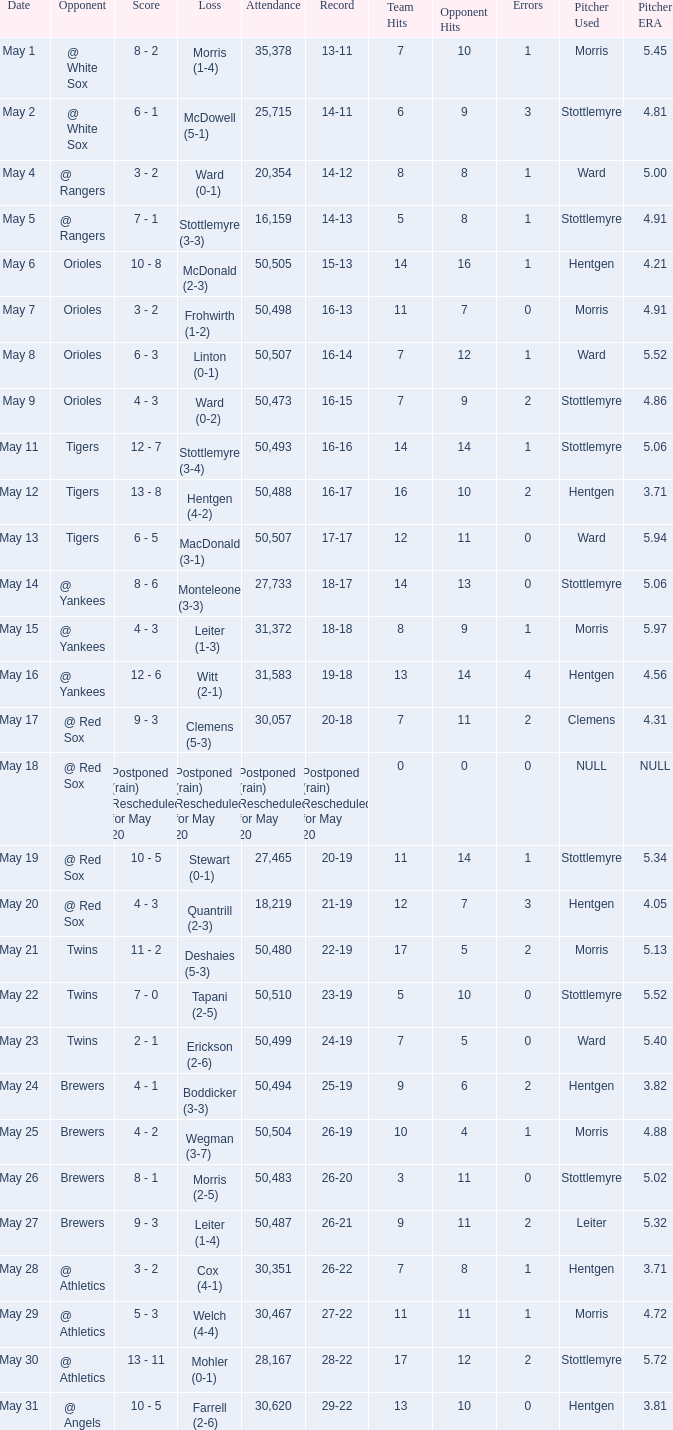What was the score of the game played on May 9? 4 - 3. 